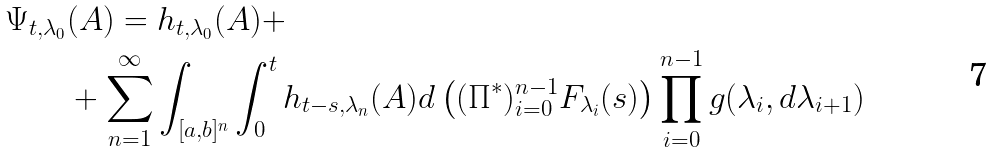<formula> <loc_0><loc_0><loc_500><loc_500>\Psi _ { t , \lambda _ { 0 } } & ( A ) = h _ { t , \lambda _ { 0 } } ( A ) + \\ & + \sum _ { n = 1 } ^ { \infty } \int _ { [ a , b ] ^ { n } } \int _ { 0 } ^ { t } h _ { t - s , \lambda _ { n } } ( A ) d \left ( ( \Pi ^ { * } ) _ { i = 0 } ^ { n - 1 } F _ { \lambda _ { i } } ( s ) \right ) \prod _ { i = 0 } ^ { n - 1 } g ( \lambda _ { i } , d \lambda _ { i + 1 } )</formula> 